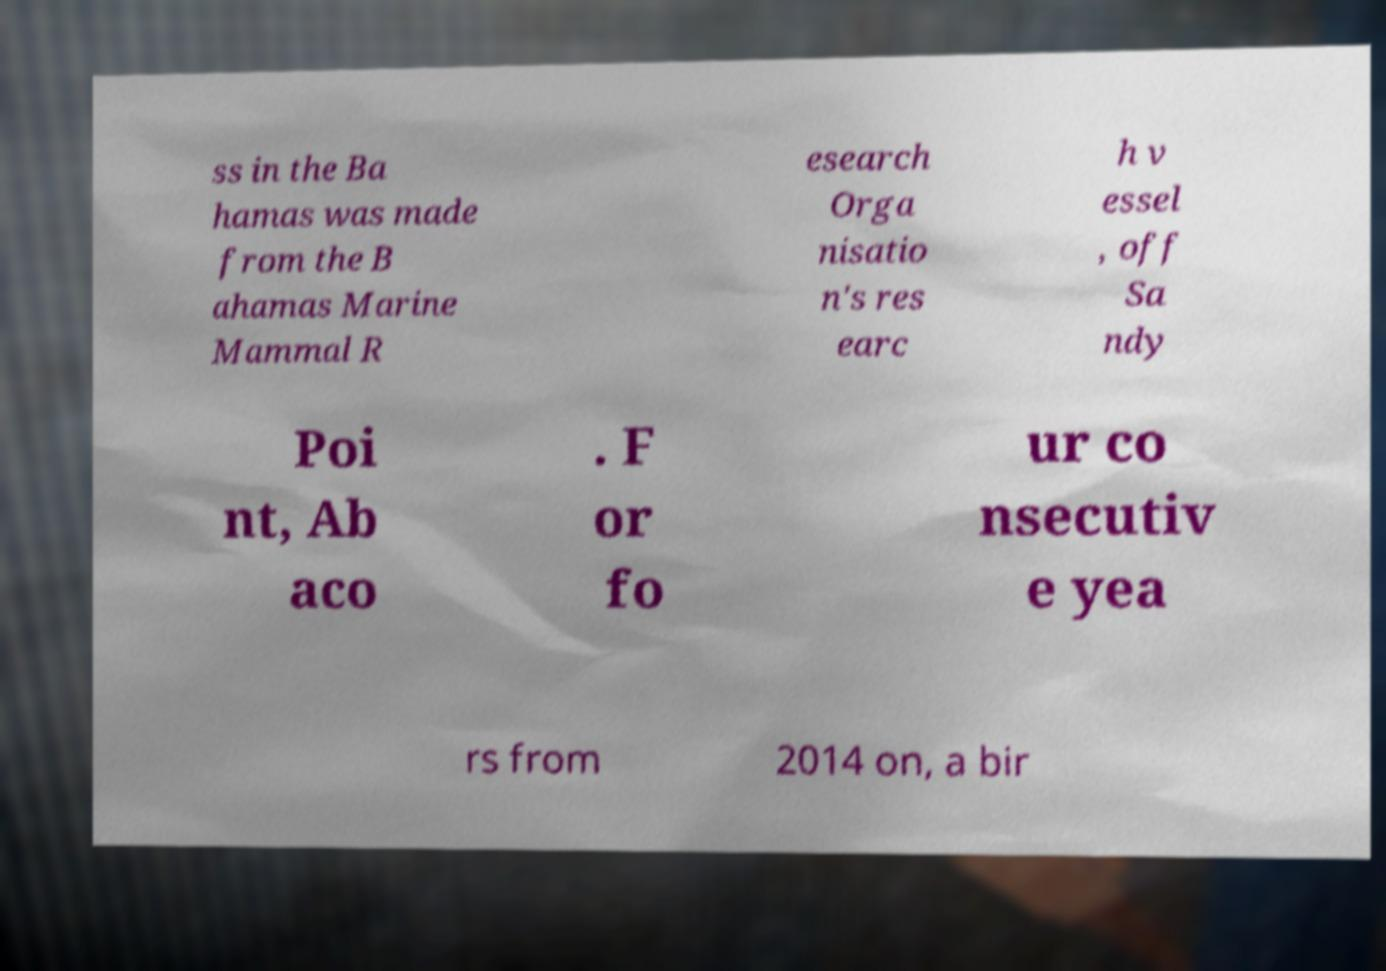Can you read and provide the text displayed in the image?This photo seems to have some interesting text. Can you extract and type it out for me? ss in the Ba hamas was made from the B ahamas Marine Mammal R esearch Orga nisatio n's res earc h v essel , off Sa ndy Poi nt, Ab aco . F or fo ur co nsecutiv e yea rs from 2014 on, a bir 